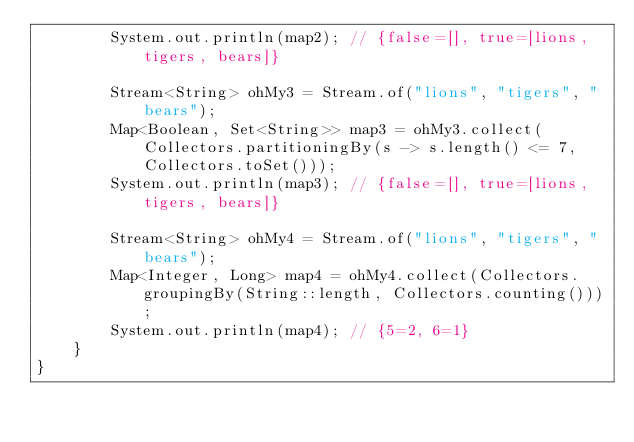<code> <loc_0><loc_0><loc_500><loc_500><_Java_>        System.out.println(map2); // {false=[], true=[lions, tigers, bears]}

        Stream<String> ohMy3 = Stream.of("lions", "tigers", "bears");
        Map<Boolean, Set<String>> map3 = ohMy3.collect(Collectors.partitioningBy(s -> s.length() <= 7, Collectors.toSet()));
        System.out.println(map3); // {false=[], true=[lions, tigers, bears]}

        Stream<String> ohMy4 = Stream.of("lions", "tigers", "bears");
        Map<Integer, Long> map4 = ohMy4.collect(Collectors.groupingBy(String::length, Collectors.counting()));
        System.out.println(map4); // {5=2, 6=1}
    }
}
</code> 